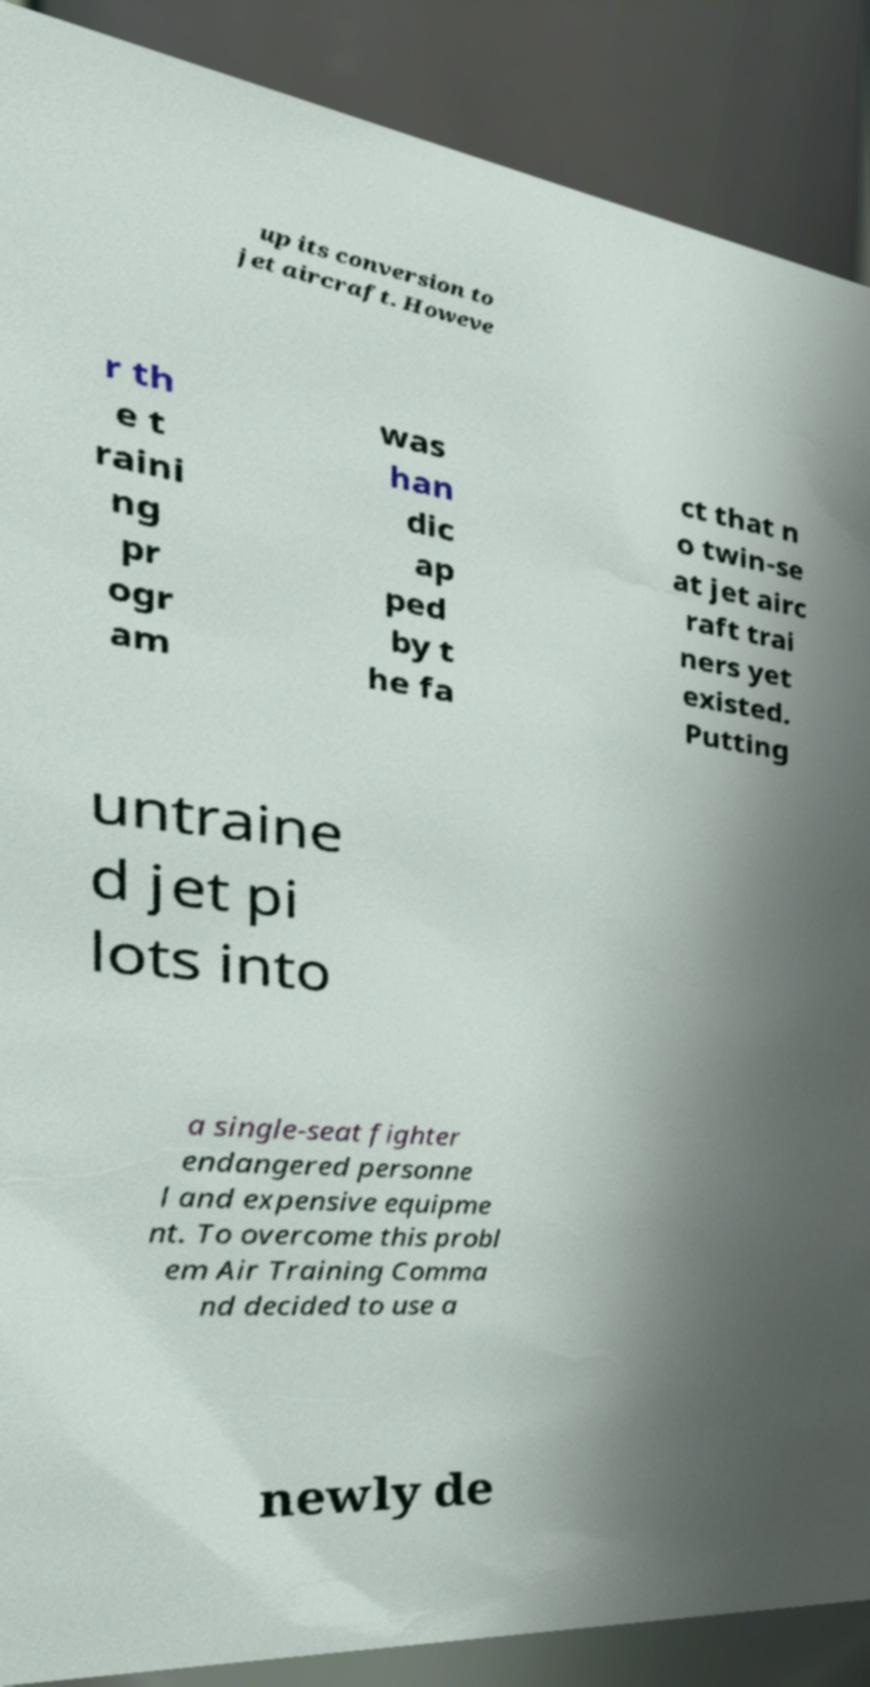For documentation purposes, I need the text within this image transcribed. Could you provide that? up its conversion to jet aircraft. Howeve r th e t raini ng pr ogr am was han dic ap ped by t he fa ct that n o twin-se at jet airc raft trai ners yet existed. Putting untraine d jet pi lots into a single-seat fighter endangered personne l and expensive equipme nt. To overcome this probl em Air Training Comma nd decided to use a newly de 